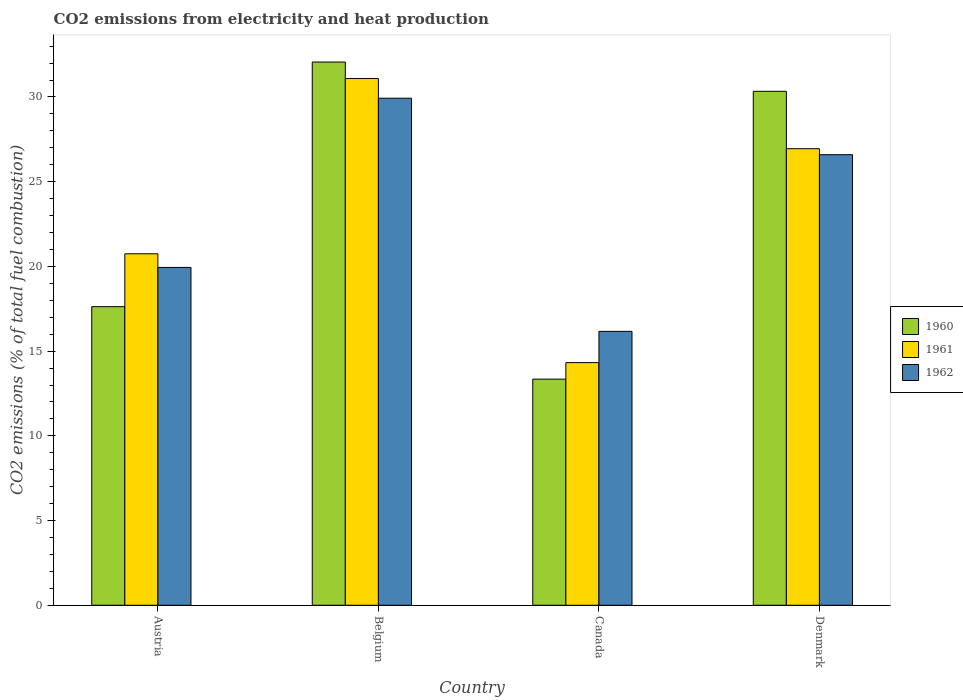How many groups of bars are there?
Provide a succinct answer. 4. What is the label of the 2nd group of bars from the left?
Your answer should be compact. Belgium. In how many cases, is the number of bars for a given country not equal to the number of legend labels?
Your answer should be compact. 0. What is the amount of CO2 emitted in 1962 in Denmark?
Your response must be concise. 26.59. Across all countries, what is the maximum amount of CO2 emitted in 1962?
Make the answer very short. 29.93. Across all countries, what is the minimum amount of CO2 emitted in 1962?
Your answer should be compact. 16.17. In which country was the amount of CO2 emitted in 1961 minimum?
Your response must be concise. Canada. What is the total amount of CO2 emitted in 1962 in the graph?
Make the answer very short. 92.63. What is the difference between the amount of CO2 emitted in 1961 in Belgium and that in Denmark?
Make the answer very short. 4.14. What is the difference between the amount of CO2 emitted in 1960 in Denmark and the amount of CO2 emitted in 1962 in Austria?
Provide a short and direct response. 10.4. What is the average amount of CO2 emitted in 1961 per country?
Your answer should be compact. 23.28. What is the difference between the amount of CO2 emitted of/in 1961 and amount of CO2 emitted of/in 1962 in Austria?
Your response must be concise. 0.81. What is the ratio of the amount of CO2 emitted in 1962 in Belgium to that in Denmark?
Ensure brevity in your answer.  1.13. Is the difference between the amount of CO2 emitted in 1961 in Belgium and Denmark greater than the difference between the amount of CO2 emitted in 1962 in Belgium and Denmark?
Provide a succinct answer. Yes. What is the difference between the highest and the second highest amount of CO2 emitted in 1960?
Keep it short and to the point. 14.44. What is the difference between the highest and the lowest amount of CO2 emitted in 1962?
Provide a succinct answer. 13.76. In how many countries, is the amount of CO2 emitted in 1961 greater than the average amount of CO2 emitted in 1961 taken over all countries?
Give a very brief answer. 2. Is the sum of the amount of CO2 emitted in 1962 in Austria and Denmark greater than the maximum amount of CO2 emitted in 1961 across all countries?
Provide a succinct answer. Yes. What does the 3rd bar from the left in Belgium represents?
Your response must be concise. 1962. Is it the case that in every country, the sum of the amount of CO2 emitted in 1961 and amount of CO2 emitted in 1962 is greater than the amount of CO2 emitted in 1960?
Ensure brevity in your answer.  Yes. Are all the bars in the graph horizontal?
Offer a terse response. No. Does the graph contain any zero values?
Provide a succinct answer. No. How many legend labels are there?
Offer a terse response. 3. How are the legend labels stacked?
Your response must be concise. Vertical. What is the title of the graph?
Keep it short and to the point. CO2 emissions from electricity and heat production. Does "2012" appear as one of the legend labels in the graph?
Your response must be concise. No. What is the label or title of the Y-axis?
Give a very brief answer. CO2 emissions (% of total fuel combustion). What is the CO2 emissions (% of total fuel combustion) in 1960 in Austria?
Offer a terse response. 17.63. What is the CO2 emissions (% of total fuel combustion) of 1961 in Austria?
Provide a short and direct response. 20.75. What is the CO2 emissions (% of total fuel combustion) in 1962 in Austria?
Your answer should be compact. 19.94. What is the CO2 emissions (% of total fuel combustion) of 1960 in Belgium?
Offer a terse response. 32.06. What is the CO2 emissions (% of total fuel combustion) in 1961 in Belgium?
Your answer should be very brief. 31.09. What is the CO2 emissions (% of total fuel combustion) in 1962 in Belgium?
Make the answer very short. 29.93. What is the CO2 emissions (% of total fuel combustion) in 1960 in Canada?
Keep it short and to the point. 13.35. What is the CO2 emissions (% of total fuel combustion) in 1961 in Canada?
Provide a succinct answer. 14.32. What is the CO2 emissions (% of total fuel combustion) in 1962 in Canada?
Offer a very short reply. 16.17. What is the CO2 emissions (% of total fuel combustion) in 1960 in Denmark?
Offer a terse response. 30.34. What is the CO2 emissions (% of total fuel combustion) in 1961 in Denmark?
Make the answer very short. 26.95. What is the CO2 emissions (% of total fuel combustion) in 1962 in Denmark?
Give a very brief answer. 26.59. Across all countries, what is the maximum CO2 emissions (% of total fuel combustion) in 1960?
Offer a very short reply. 32.06. Across all countries, what is the maximum CO2 emissions (% of total fuel combustion) in 1961?
Offer a very short reply. 31.09. Across all countries, what is the maximum CO2 emissions (% of total fuel combustion) of 1962?
Make the answer very short. 29.93. Across all countries, what is the minimum CO2 emissions (% of total fuel combustion) of 1960?
Make the answer very short. 13.35. Across all countries, what is the minimum CO2 emissions (% of total fuel combustion) in 1961?
Offer a very short reply. 14.32. Across all countries, what is the minimum CO2 emissions (% of total fuel combustion) in 1962?
Make the answer very short. 16.17. What is the total CO2 emissions (% of total fuel combustion) of 1960 in the graph?
Your answer should be compact. 93.37. What is the total CO2 emissions (% of total fuel combustion) of 1961 in the graph?
Keep it short and to the point. 93.1. What is the total CO2 emissions (% of total fuel combustion) in 1962 in the graph?
Offer a very short reply. 92.63. What is the difference between the CO2 emissions (% of total fuel combustion) of 1960 in Austria and that in Belgium?
Make the answer very short. -14.44. What is the difference between the CO2 emissions (% of total fuel combustion) of 1961 in Austria and that in Belgium?
Your response must be concise. -10.34. What is the difference between the CO2 emissions (% of total fuel combustion) of 1962 in Austria and that in Belgium?
Provide a short and direct response. -9.99. What is the difference between the CO2 emissions (% of total fuel combustion) in 1960 in Austria and that in Canada?
Provide a short and direct response. 4.28. What is the difference between the CO2 emissions (% of total fuel combustion) in 1961 in Austria and that in Canada?
Give a very brief answer. 6.42. What is the difference between the CO2 emissions (% of total fuel combustion) of 1962 in Austria and that in Canada?
Make the answer very short. 3.77. What is the difference between the CO2 emissions (% of total fuel combustion) in 1960 in Austria and that in Denmark?
Offer a very short reply. -12.71. What is the difference between the CO2 emissions (% of total fuel combustion) in 1961 in Austria and that in Denmark?
Keep it short and to the point. -6.2. What is the difference between the CO2 emissions (% of total fuel combustion) of 1962 in Austria and that in Denmark?
Provide a succinct answer. -6.65. What is the difference between the CO2 emissions (% of total fuel combustion) in 1960 in Belgium and that in Canada?
Make the answer very short. 18.72. What is the difference between the CO2 emissions (% of total fuel combustion) in 1961 in Belgium and that in Canada?
Your answer should be compact. 16.77. What is the difference between the CO2 emissions (% of total fuel combustion) in 1962 in Belgium and that in Canada?
Make the answer very short. 13.76. What is the difference between the CO2 emissions (% of total fuel combustion) in 1960 in Belgium and that in Denmark?
Provide a succinct answer. 1.73. What is the difference between the CO2 emissions (% of total fuel combustion) of 1961 in Belgium and that in Denmark?
Your answer should be compact. 4.14. What is the difference between the CO2 emissions (% of total fuel combustion) of 1962 in Belgium and that in Denmark?
Your response must be concise. 3.33. What is the difference between the CO2 emissions (% of total fuel combustion) of 1960 in Canada and that in Denmark?
Your answer should be very brief. -16.99. What is the difference between the CO2 emissions (% of total fuel combustion) of 1961 in Canada and that in Denmark?
Your answer should be compact. -12.63. What is the difference between the CO2 emissions (% of total fuel combustion) of 1962 in Canada and that in Denmark?
Make the answer very short. -10.43. What is the difference between the CO2 emissions (% of total fuel combustion) of 1960 in Austria and the CO2 emissions (% of total fuel combustion) of 1961 in Belgium?
Provide a succinct answer. -13.46. What is the difference between the CO2 emissions (% of total fuel combustion) in 1960 in Austria and the CO2 emissions (% of total fuel combustion) in 1962 in Belgium?
Give a very brief answer. -12.3. What is the difference between the CO2 emissions (% of total fuel combustion) of 1961 in Austria and the CO2 emissions (% of total fuel combustion) of 1962 in Belgium?
Ensure brevity in your answer.  -9.18. What is the difference between the CO2 emissions (% of total fuel combustion) in 1960 in Austria and the CO2 emissions (% of total fuel combustion) in 1961 in Canada?
Your answer should be compact. 3.3. What is the difference between the CO2 emissions (% of total fuel combustion) of 1960 in Austria and the CO2 emissions (% of total fuel combustion) of 1962 in Canada?
Ensure brevity in your answer.  1.46. What is the difference between the CO2 emissions (% of total fuel combustion) of 1961 in Austria and the CO2 emissions (% of total fuel combustion) of 1962 in Canada?
Offer a terse response. 4.58. What is the difference between the CO2 emissions (% of total fuel combustion) in 1960 in Austria and the CO2 emissions (% of total fuel combustion) in 1961 in Denmark?
Provide a succinct answer. -9.32. What is the difference between the CO2 emissions (% of total fuel combustion) in 1960 in Austria and the CO2 emissions (% of total fuel combustion) in 1962 in Denmark?
Give a very brief answer. -8.97. What is the difference between the CO2 emissions (% of total fuel combustion) in 1961 in Austria and the CO2 emissions (% of total fuel combustion) in 1962 in Denmark?
Ensure brevity in your answer.  -5.85. What is the difference between the CO2 emissions (% of total fuel combustion) in 1960 in Belgium and the CO2 emissions (% of total fuel combustion) in 1961 in Canada?
Keep it short and to the point. 17.74. What is the difference between the CO2 emissions (% of total fuel combustion) of 1960 in Belgium and the CO2 emissions (% of total fuel combustion) of 1962 in Canada?
Offer a terse response. 15.9. What is the difference between the CO2 emissions (% of total fuel combustion) in 1961 in Belgium and the CO2 emissions (% of total fuel combustion) in 1962 in Canada?
Give a very brief answer. 14.92. What is the difference between the CO2 emissions (% of total fuel combustion) in 1960 in Belgium and the CO2 emissions (% of total fuel combustion) in 1961 in Denmark?
Give a very brief answer. 5.11. What is the difference between the CO2 emissions (% of total fuel combustion) in 1960 in Belgium and the CO2 emissions (% of total fuel combustion) in 1962 in Denmark?
Your answer should be very brief. 5.47. What is the difference between the CO2 emissions (% of total fuel combustion) of 1961 in Belgium and the CO2 emissions (% of total fuel combustion) of 1962 in Denmark?
Keep it short and to the point. 4.5. What is the difference between the CO2 emissions (% of total fuel combustion) in 1960 in Canada and the CO2 emissions (% of total fuel combustion) in 1961 in Denmark?
Provide a short and direct response. -13.6. What is the difference between the CO2 emissions (% of total fuel combustion) of 1960 in Canada and the CO2 emissions (% of total fuel combustion) of 1962 in Denmark?
Your answer should be compact. -13.25. What is the difference between the CO2 emissions (% of total fuel combustion) in 1961 in Canada and the CO2 emissions (% of total fuel combustion) in 1962 in Denmark?
Provide a succinct answer. -12.27. What is the average CO2 emissions (% of total fuel combustion) of 1960 per country?
Your answer should be compact. 23.34. What is the average CO2 emissions (% of total fuel combustion) of 1961 per country?
Offer a terse response. 23.28. What is the average CO2 emissions (% of total fuel combustion) in 1962 per country?
Your response must be concise. 23.16. What is the difference between the CO2 emissions (% of total fuel combustion) of 1960 and CO2 emissions (% of total fuel combustion) of 1961 in Austria?
Provide a succinct answer. -3.12. What is the difference between the CO2 emissions (% of total fuel combustion) of 1960 and CO2 emissions (% of total fuel combustion) of 1962 in Austria?
Provide a short and direct response. -2.31. What is the difference between the CO2 emissions (% of total fuel combustion) of 1961 and CO2 emissions (% of total fuel combustion) of 1962 in Austria?
Your response must be concise. 0.81. What is the difference between the CO2 emissions (% of total fuel combustion) of 1960 and CO2 emissions (% of total fuel combustion) of 1961 in Belgium?
Provide a short and direct response. 0.97. What is the difference between the CO2 emissions (% of total fuel combustion) in 1960 and CO2 emissions (% of total fuel combustion) in 1962 in Belgium?
Your answer should be compact. 2.14. What is the difference between the CO2 emissions (% of total fuel combustion) of 1961 and CO2 emissions (% of total fuel combustion) of 1962 in Belgium?
Provide a short and direct response. 1.16. What is the difference between the CO2 emissions (% of total fuel combustion) in 1960 and CO2 emissions (% of total fuel combustion) in 1961 in Canada?
Make the answer very short. -0.98. What is the difference between the CO2 emissions (% of total fuel combustion) in 1960 and CO2 emissions (% of total fuel combustion) in 1962 in Canada?
Provide a succinct answer. -2.82. What is the difference between the CO2 emissions (% of total fuel combustion) of 1961 and CO2 emissions (% of total fuel combustion) of 1962 in Canada?
Give a very brief answer. -1.85. What is the difference between the CO2 emissions (% of total fuel combustion) in 1960 and CO2 emissions (% of total fuel combustion) in 1961 in Denmark?
Give a very brief answer. 3.39. What is the difference between the CO2 emissions (% of total fuel combustion) in 1960 and CO2 emissions (% of total fuel combustion) in 1962 in Denmark?
Ensure brevity in your answer.  3.74. What is the difference between the CO2 emissions (% of total fuel combustion) of 1961 and CO2 emissions (% of total fuel combustion) of 1962 in Denmark?
Give a very brief answer. 0.35. What is the ratio of the CO2 emissions (% of total fuel combustion) of 1960 in Austria to that in Belgium?
Your answer should be compact. 0.55. What is the ratio of the CO2 emissions (% of total fuel combustion) of 1961 in Austria to that in Belgium?
Offer a terse response. 0.67. What is the ratio of the CO2 emissions (% of total fuel combustion) in 1962 in Austria to that in Belgium?
Your answer should be compact. 0.67. What is the ratio of the CO2 emissions (% of total fuel combustion) in 1960 in Austria to that in Canada?
Ensure brevity in your answer.  1.32. What is the ratio of the CO2 emissions (% of total fuel combustion) in 1961 in Austria to that in Canada?
Ensure brevity in your answer.  1.45. What is the ratio of the CO2 emissions (% of total fuel combustion) of 1962 in Austria to that in Canada?
Your answer should be very brief. 1.23. What is the ratio of the CO2 emissions (% of total fuel combustion) of 1960 in Austria to that in Denmark?
Your answer should be very brief. 0.58. What is the ratio of the CO2 emissions (% of total fuel combustion) in 1961 in Austria to that in Denmark?
Make the answer very short. 0.77. What is the ratio of the CO2 emissions (% of total fuel combustion) of 1962 in Austria to that in Denmark?
Your answer should be very brief. 0.75. What is the ratio of the CO2 emissions (% of total fuel combustion) in 1960 in Belgium to that in Canada?
Provide a succinct answer. 2.4. What is the ratio of the CO2 emissions (% of total fuel combustion) in 1961 in Belgium to that in Canada?
Provide a short and direct response. 2.17. What is the ratio of the CO2 emissions (% of total fuel combustion) in 1962 in Belgium to that in Canada?
Keep it short and to the point. 1.85. What is the ratio of the CO2 emissions (% of total fuel combustion) of 1960 in Belgium to that in Denmark?
Ensure brevity in your answer.  1.06. What is the ratio of the CO2 emissions (% of total fuel combustion) in 1961 in Belgium to that in Denmark?
Your response must be concise. 1.15. What is the ratio of the CO2 emissions (% of total fuel combustion) in 1962 in Belgium to that in Denmark?
Provide a short and direct response. 1.13. What is the ratio of the CO2 emissions (% of total fuel combustion) of 1960 in Canada to that in Denmark?
Ensure brevity in your answer.  0.44. What is the ratio of the CO2 emissions (% of total fuel combustion) in 1961 in Canada to that in Denmark?
Offer a very short reply. 0.53. What is the ratio of the CO2 emissions (% of total fuel combustion) in 1962 in Canada to that in Denmark?
Offer a very short reply. 0.61. What is the difference between the highest and the second highest CO2 emissions (% of total fuel combustion) of 1960?
Keep it short and to the point. 1.73. What is the difference between the highest and the second highest CO2 emissions (% of total fuel combustion) of 1961?
Keep it short and to the point. 4.14. What is the difference between the highest and the second highest CO2 emissions (% of total fuel combustion) in 1962?
Keep it short and to the point. 3.33. What is the difference between the highest and the lowest CO2 emissions (% of total fuel combustion) in 1960?
Your answer should be compact. 18.72. What is the difference between the highest and the lowest CO2 emissions (% of total fuel combustion) in 1961?
Give a very brief answer. 16.77. What is the difference between the highest and the lowest CO2 emissions (% of total fuel combustion) of 1962?
Provide a short and direct response. 13.76. 